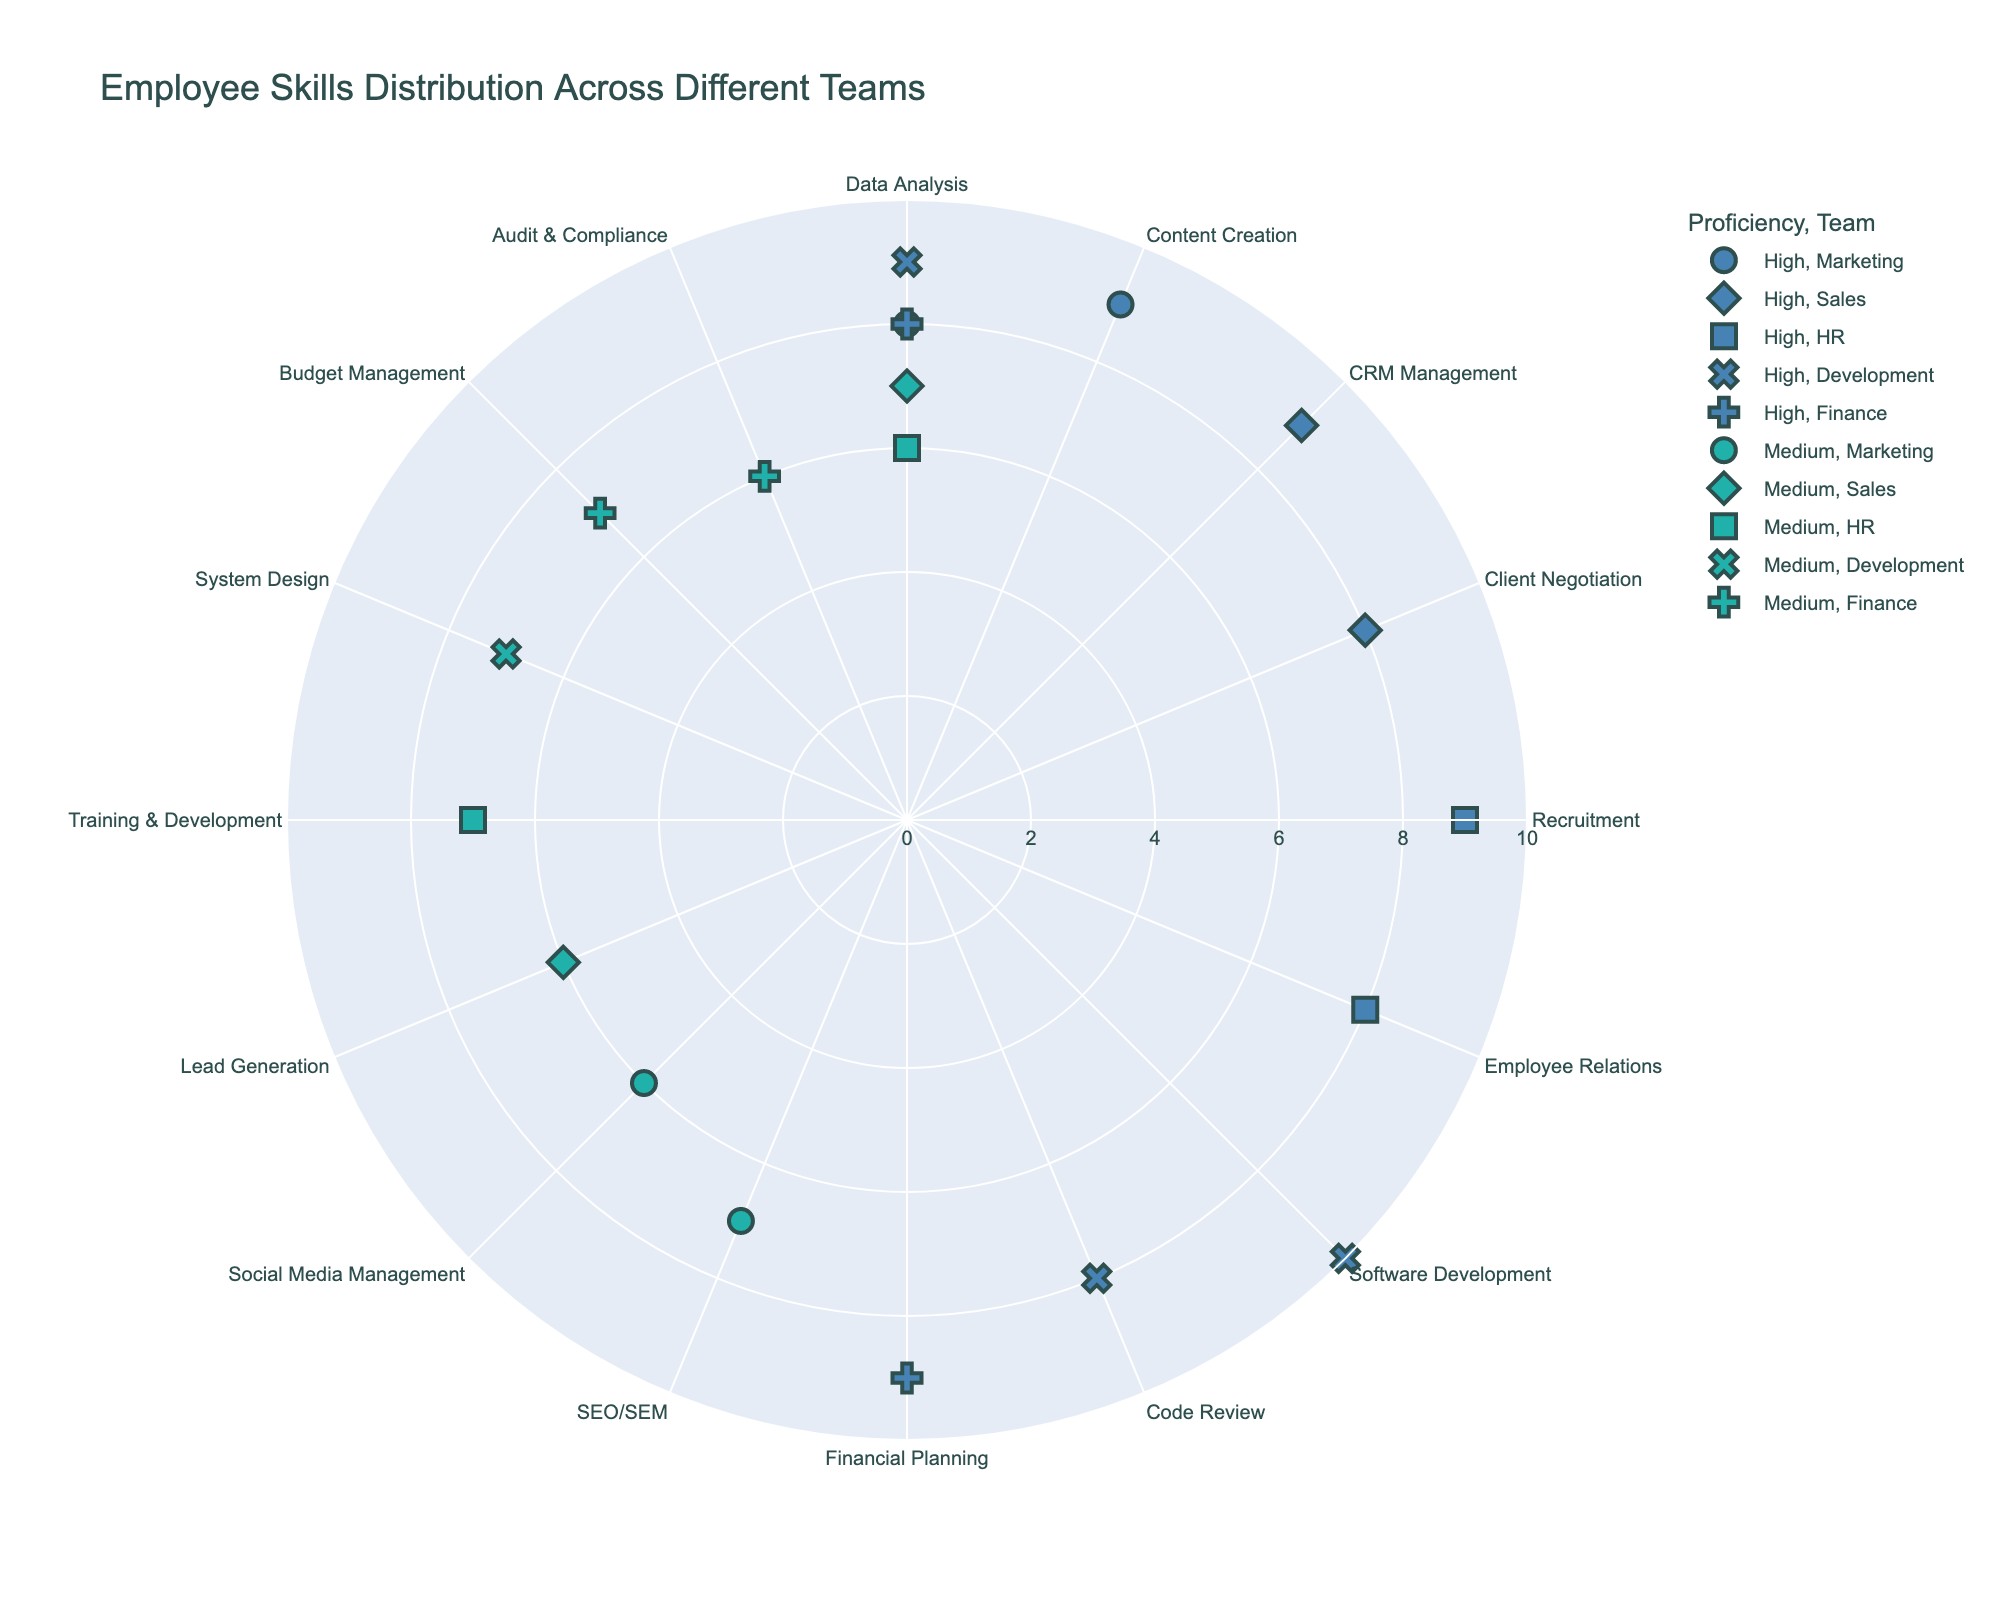How many skills are rated with a proficiency level of 'High'? Count the number of data points colored with the shade that represents 'High' proficiency across all teams.
Answer: 11 Which team has the highest skill level in Data Analysis? Identify the points representing "Data Analysis", then find the one with the highest radial value. The team symbol will indicate the team.
Answer: Development What is the average skill level for the Finance team? Sum the skill levels of all points representing the Finance team and divide by the number of those points.
Answer: 7.5 How does the number of high proficiency skills compare between Marketing and Sales? Count the high proficiency skills in both teams and compare the counts. Marketing has 2: Data Analysis and Content Creation. Sales has 2: CRM Management and Client Negotiation.
Answer: Equal Which skill shows the maximum difference in proficiency levels across teams? Identify the skills which are present across multiple teams and compute the proficiency level difference, then find the maximum. Skills present across multiple teams include "Data Analysis". It has levels of 8 (Marketing), 7 (Sales), 6 (HR), and 9 (Development), so the difference is max(9) - min(6) = 3.
Answer: Data Analysis Is there any skill level that is present in all teams? Check if any specific skill appears across all teams. "Data Analysis" is present in Marketing, Sales, HR, Development, and Finance.
Answer: Yes Which skill has the lowest proficiency level in the Finance team? Look at the Financing team and identify the skill with the lowest radial value.
Answer: Audit & Compliance How does 'Social Media Management' proficiency compare to other Marketing skills? Compare the radial values (skill levels) of "Social Media Management" with other skills in the Marketing team. "Social Media Management" has a skill level of 6, while others (Data Analysis: 8, SEO/SEM: 7, Content Creation: 9) are higher.
Answer: Lower What is the range of skill levels for the Development team? Identify the minimum and maximum skill levels in the Development team and subtract the minimum from the maximum.
Answer: 3 